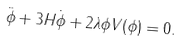Convert formula to latex. <formula><loc_0><loc_0><loc_500><loc_500>\ddot { \phi } + 3 H \dot { \phi } + 2 \lambda { \phi } V ( \phi ) = 0 .</formula> 